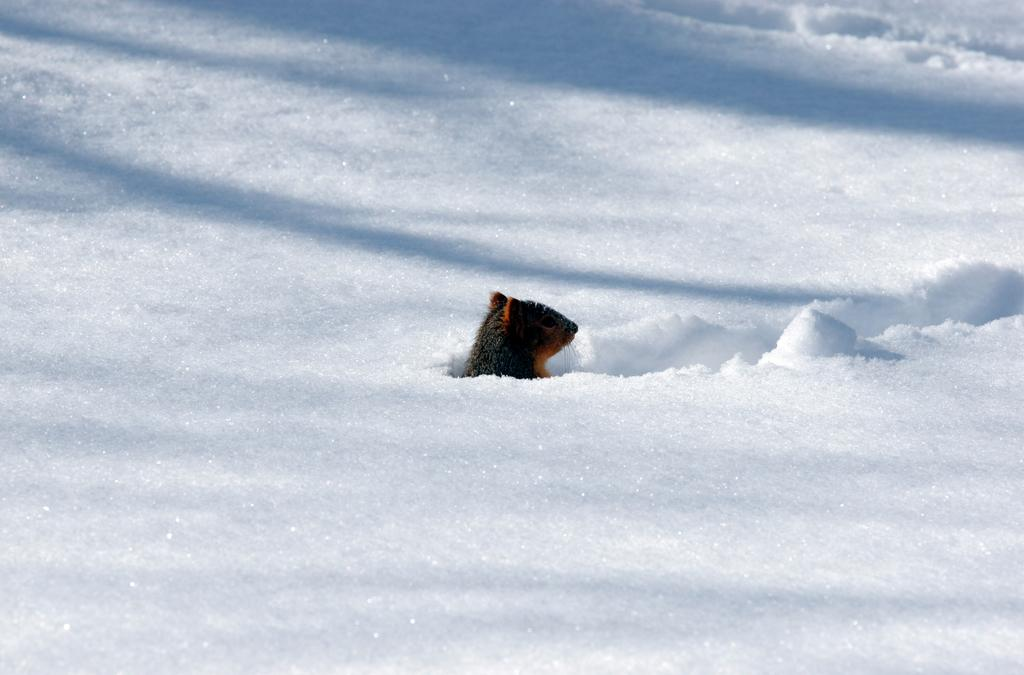What is the main subject of the image? The main subject of the image is a bus. Can you describe the setting in which the bus is located? The bus is in the snow. What type of feather can be seen on the bus in the image? There is no feather present on the bus in the image. What kind of loaf is being served on the bus in the image? There is no loaf present on the bus in the image. 